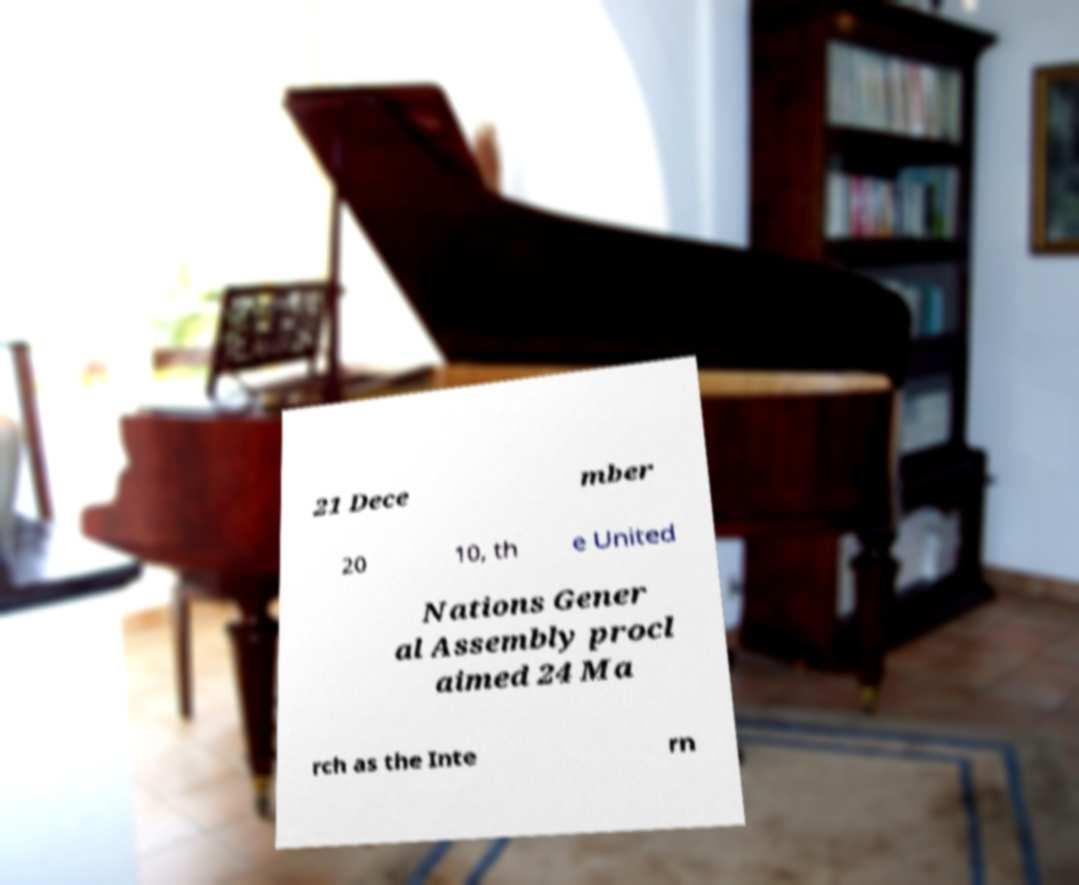What messages or text are displayed in this image? I need them in a readable, typed format. 21 Dece mber 20 10, th e United Nations Gener al Assembly procl aimed 24 Ma rch as the Inte rn 